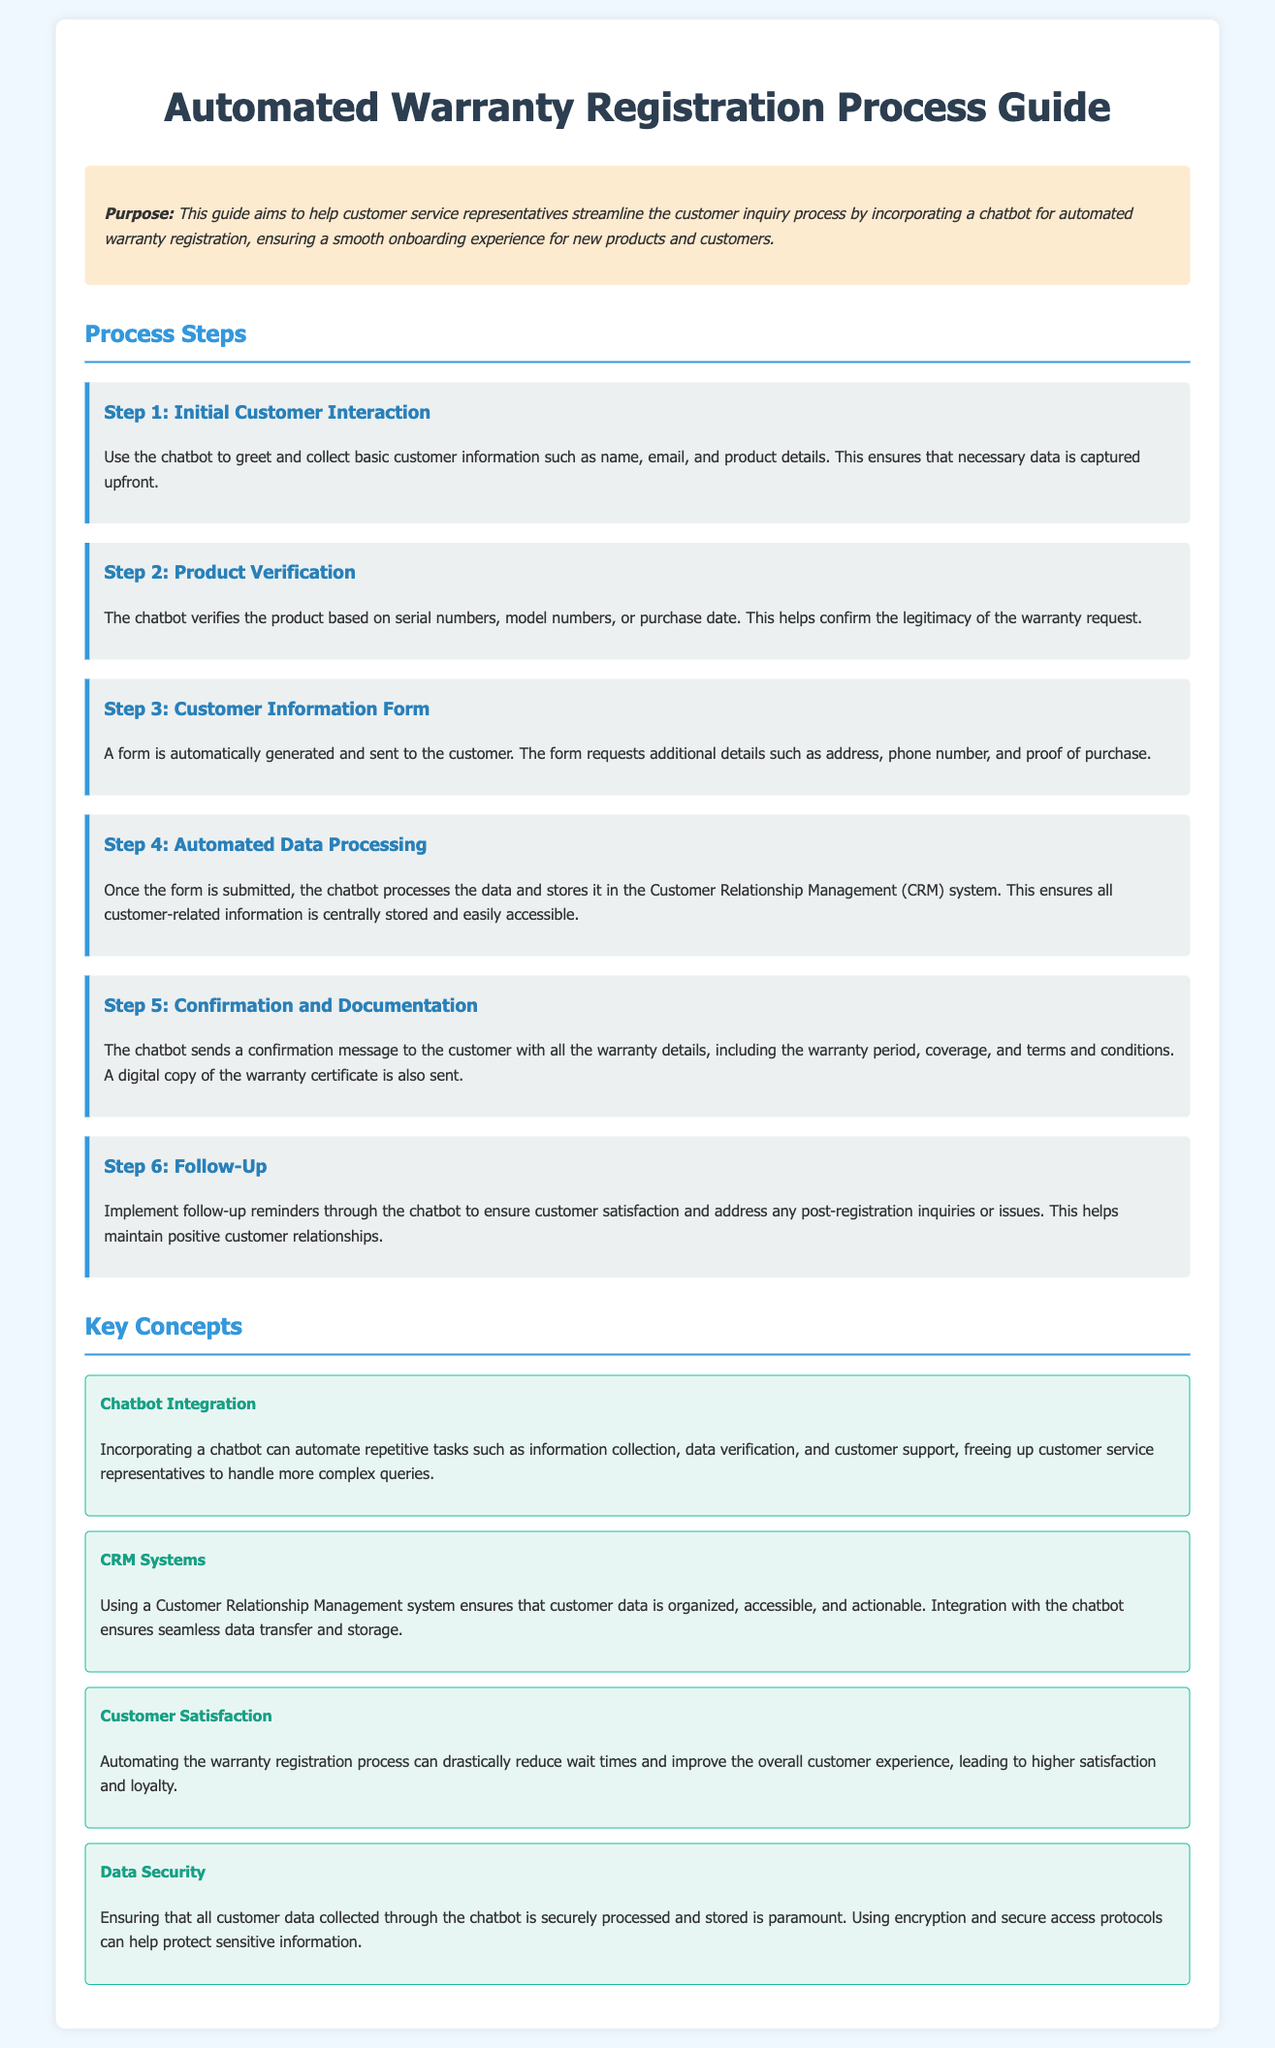What is the purpose of the guide? The purpose is to help customer service representatives streamline the customer inquiry process by incorporating a chatbot for automated warranty registration.
Answer: Streamline customer inquiry process What step involves customer data collection? Step 1 specifically mentions collecting basic customer information such as name, email, and product details.
Answer: Step 1 What does the chatbot verify in Step 2? In Step 2, the chatbot verifies the product based on serial numbers, model numbers, or purchase date.
Answer: Product legitimacy How many steps are there in the process? The document outlines six distinct steps in the automated warranty registration process.
Answer: Six What kind of system is used to store customer data in Step 4? In Step 4, the data is stored in a Customer Relationship Management system.
Answer: CRM system What does the confirmation message include in Step 5? The confirmation message includes warranty details such as the warranty period, coverage, and terms and conditions.
Answer: Warranty details What is a key benefit mentioned regarding customer satisfaction? The document states that automating the warranty registration process can drastically reduce wait times, improving overall customer experience.
Answer: Reduce wait times What does the concept of Data Security emphasize? The concept emphasizes ensuring customer data is securely processed and stored using encryption and secure access protocols.
Answer: Securely processed and stored How does the guide suggest maintaining customer relationships after registration? It suggests implementing follow-up reminders through the chatbot to ensure customer satisfaction and address any inquiries.
Answer: Follow-up reminders 